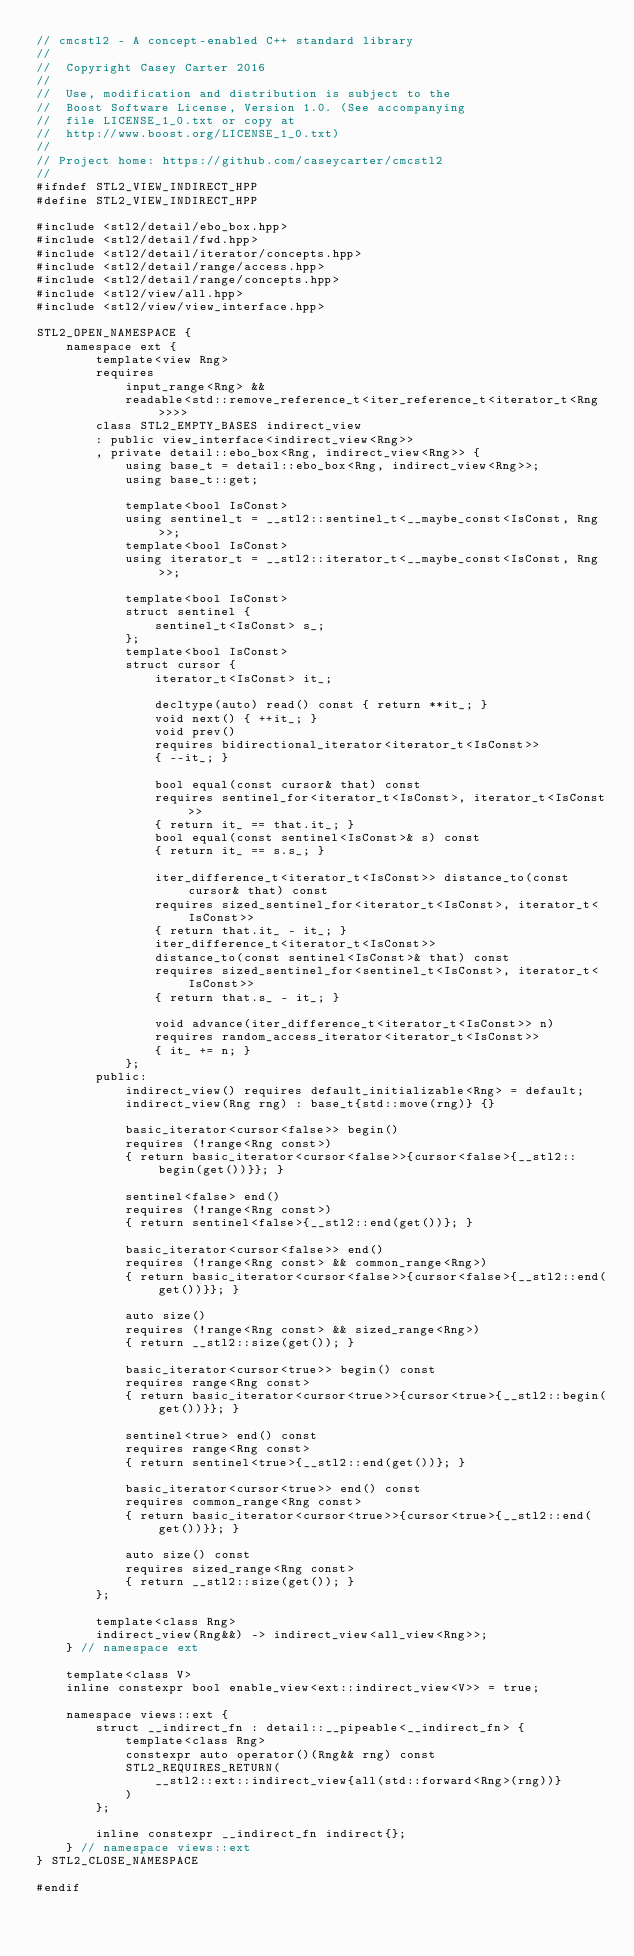<code> <loc_0><loc_0><loc_500><loc_500><_C++_>// cmcstl2 - A concept-enabled C++ standard library
//
//  Copyright Casey Carter 2016
//
//  Use, modification and distribution is subject to the
//  Boost Software License, Version 1.0. (See accompanying
//  file LICENSE_1_0.txt or copy at
//  http://www.boost.org/LICENSE_1_0.txt)
//
// Project home: https://github.com/caseycarter/cmcstl2
//
#ifndef STL2_VIEW_INDIRECT_HPP
#define STL2_VIEW_INDIRECT_HPP

#include <stl2/detail/ebo_box.hpp>
#include <stl2/detail/fwd.hpp>
#include <stl2/detail/iterator/concepts.hpp>
#include <stl2/detail/range/access.hpp>
#include <stl2/detail/range/concepts.hpp>
#include <stl2/view/all.hpp>
#include <stl2/view/view_interface.hpp>

STL2_OPEN_NAMESPACE {
	namespace ext {
		template<view Rng>
		requires
			input_range<Rng> &&
			readable<std::remove_reference_t<iter_reference_t<iterator_t<Rng>>>>
		class STL2_EMPTY_BASES indirect_view
		: public view_interface<indirect_view<Rng>>
		, private detail::ebo_box<Rng, indirect_view<Rng>> {
			using base_t = detail::ebo_box<Rng, indirect_view<Rng>>;
			using base_t::get;

			template<bool IsConst>
			using sentinel_t = __stl2::sentinel_t<__maybe_const<IsConst, Rng>>;
			template<bool IsConst>
			using iterator_t = __stl2::iterator_t<__maybe_const<IsConst, Rng>>;

			template<bool IsConst>
			struct sentinel {
				sentinel_t<IsConst> s_;
			};
			template<bool IsConst>
			struct cursor {
				iterator_t<IsConst> it_;

				decltype(auto) read() const { return **it_; }
				void next() { ++it_; }
				void prev()
				requires bidirectional_iterator<iterator_t<IsConst>>
				{ --it_; }

				bool equal(const cursor& that) const
				requires sentinel_for<iterator_t<IsConst>, iterator_t<IsConst>>
				{ return it_ == that.it_; }
				bool equal(const sentinel<IsConst>& s) const
				{ return it_ == s.s_; }

				iter_difference_t<iterator_t<IsConst>> distance_to(const cursor& that) const
				requires sized_sentinel_for<iterator_t<IsConst>, iterator_t<IsConst>>
				{ return that.it_ - it_; }
				iter_difference_t<iterator_t<IsConst>>
				distance_to(const sentinel<IsConst>& that) const
				requires sized_sentinel_for<sentinel_t<IsConst>, iterator_t<IsConst>>
				{ return that.s_ - it_; }

				void advance(iter_difference_t<iterator_t<IsConst>> n)
				requires random_access_iterator<iterator_t<IsConst>>
				{ it_ += n; }
			};
		public:
			indirect_view() requires default_initializable<Rng> = default;
			indirect_view(Rng rng) : base_t{std::move(rng)} {}

			basic_iterator<cursor<false>> begin()
			requires (!range<Rng const>)
			{ return basic_iterator<cursor<false>>{cursor<false>{__stl2::begin(get())}}; }

			sentinel<false> end()
			requires (!range<Rng const>)
			{ return sentinel<false>{__stl2::end(get())}; }

			basic_iterator<cursor<false>> end()
			requires (!range<Rng const> && common_range<Rng>)
			{ return basic_iterator<cursor<false>>{cursor<false>{__stl2::end(get())}}; }

			auto size()
			requires (!range<Rng const> && sized_range<Rng>)
			{ return __stl2::size(get()); }

			basic_iterator<cursor<true>> begin() const
			requires range<Rng const>
			{ return basic_iterator<cursor<true>>{cursor<true>{__stl2::begin(get())}}; }

			sentinel<true> end() const
			requires range<Rng const>
			{ return sentinel<true>{__stl2::end(get())}; }

			basic_iterator<cursor<true>> end() const
			requires common_range<Rng const>
			{ return basic_iterator<cursor<true>>{cursor<true>{__stl2::end(get())}}; }

			auto size() const
			requires sized_range<Rng const>
			{ return __stl2::size(get()); }
		};

		template<class Rng>
		indirect_view(Rng&&) -> indirect_view<all_view<Rng>>;
	} // namespace ext

	template<class V>
	inline constexpr bool enable_view<ext::indirect_view<V>> = true;

	namespace views::ext {
		struct __indirect_fn : detail::__pipeable<__indirect_fn> {
			template<class Rng>
			constexpr auto operator()(Rng&& rng) const
			STL2_REQUIRES_RETURN(
				__stl2::ext::indirect_view{all(std::forward<Rng>(rng))}
			)
		};

		inline constexpr __indirect_fn indirect{};
	} // namespace views::ext
} STL2_CLOSE_NAMESPACE

#endif
</code> 